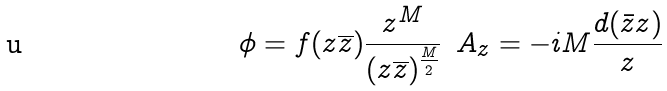Convert formula to latex. <formula><loc_0><loc_0><loc_500><loc_500>\phi = f ( z \overline { z } ) \frac { z ^ { M } } { ( z \overline { z } ) ^ { \frac { M } { 2 } } } \, \ A _ { z } = - i M \frac { d ( \bar { z } z ) } { z }</formula> 